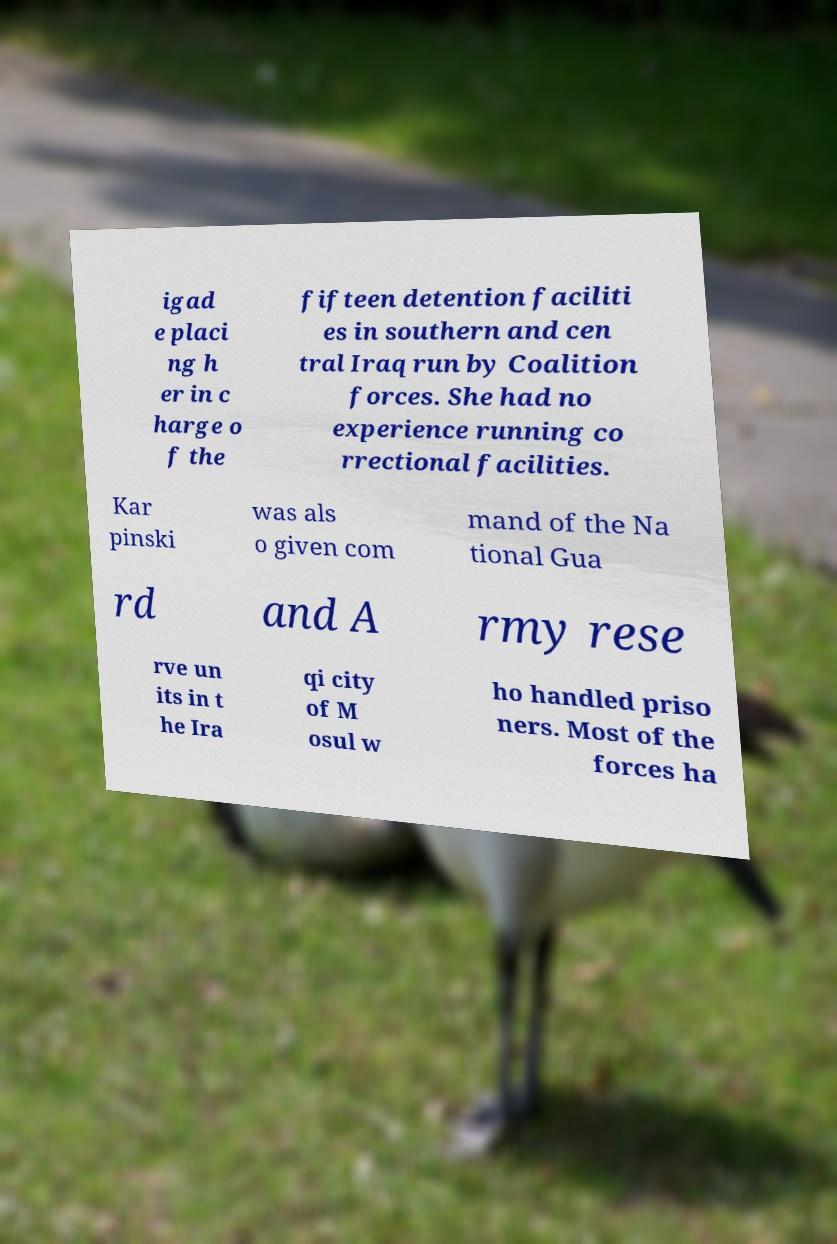What messages or text are displayed in this image? I need them in a readable, typed format. igad e placi ng h er in c harge o f the fifteen detention faciliti es in southern and cen tral Iraq run by Coalition forces. She had no experience running co rrectional facilities. Kar pinski was als o given com mand of the Na tional Gua rd and A rmy rese rve un its in t he Ira qi city of M osul w ho handled priso ners. Most of the forces ha 